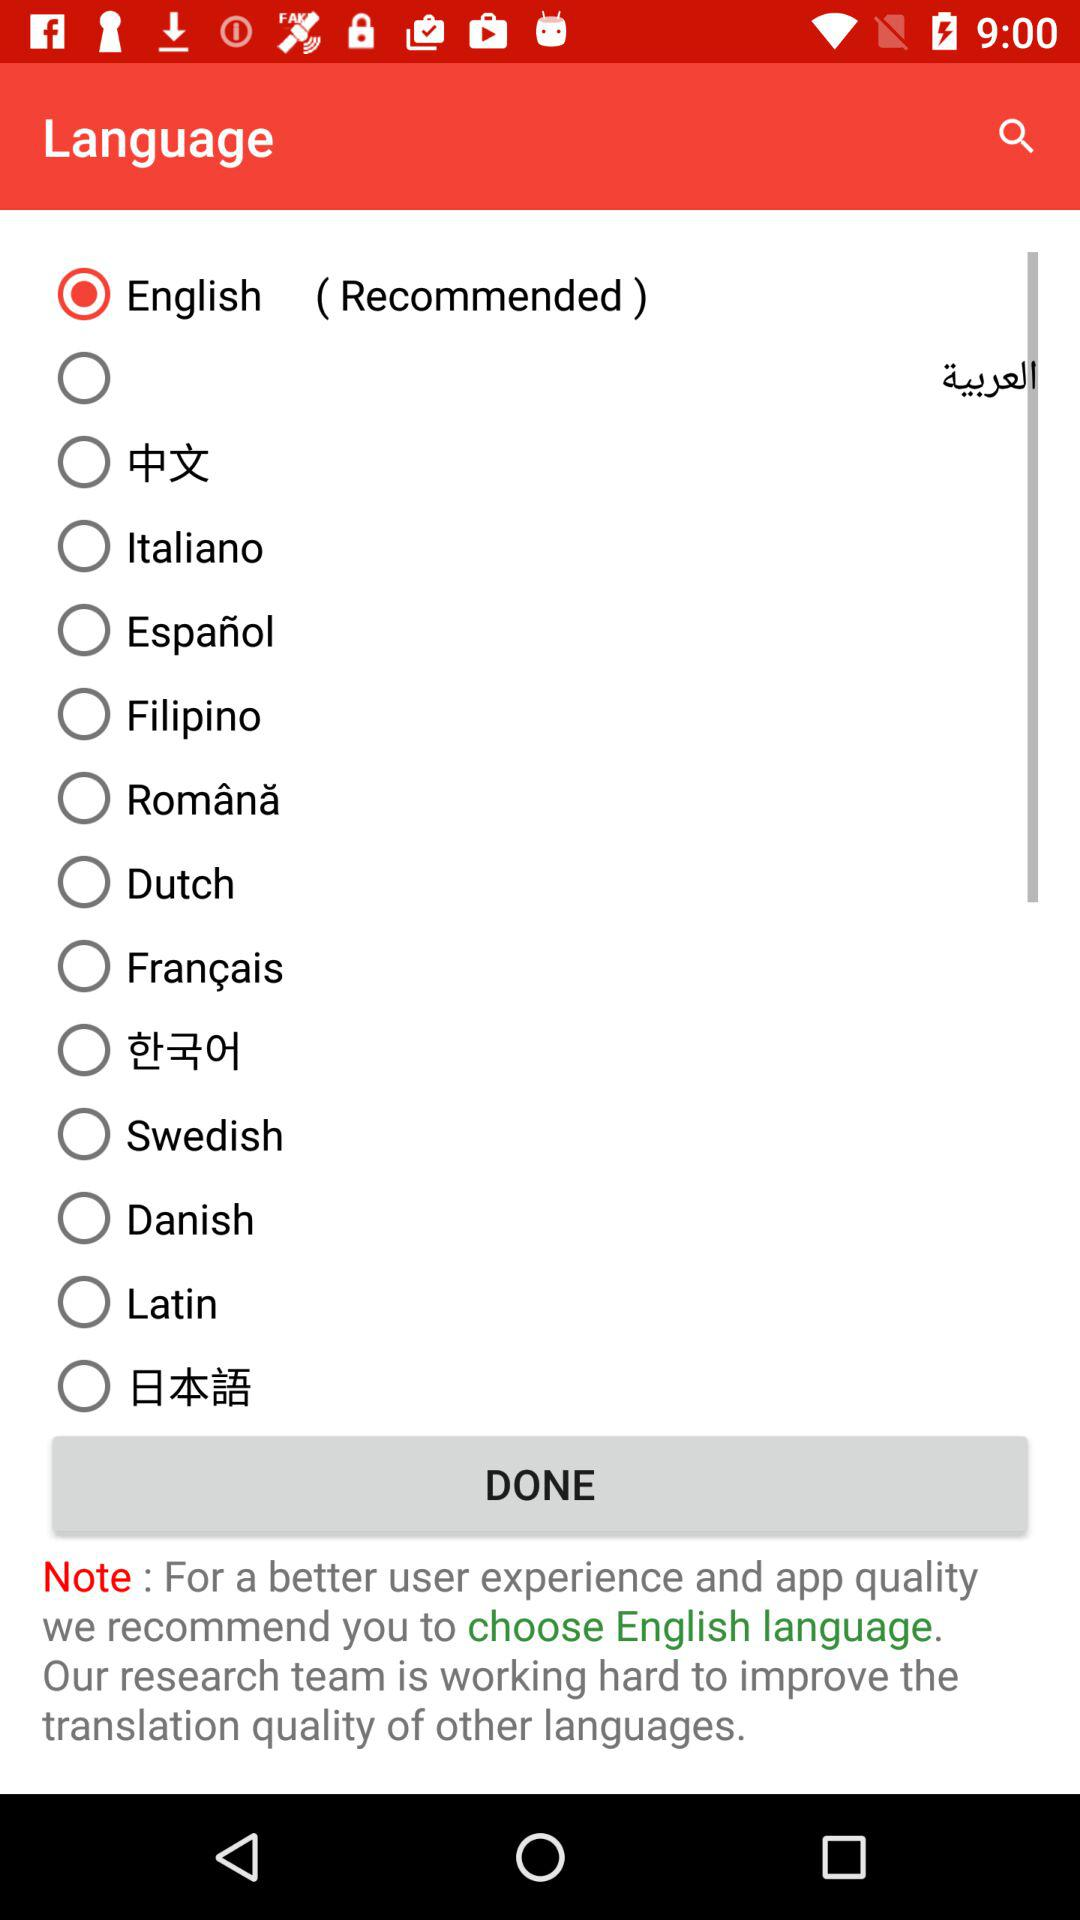Which version of the application is this?
When the provided information is insufficient, respond with <no answer>. <no answer> 